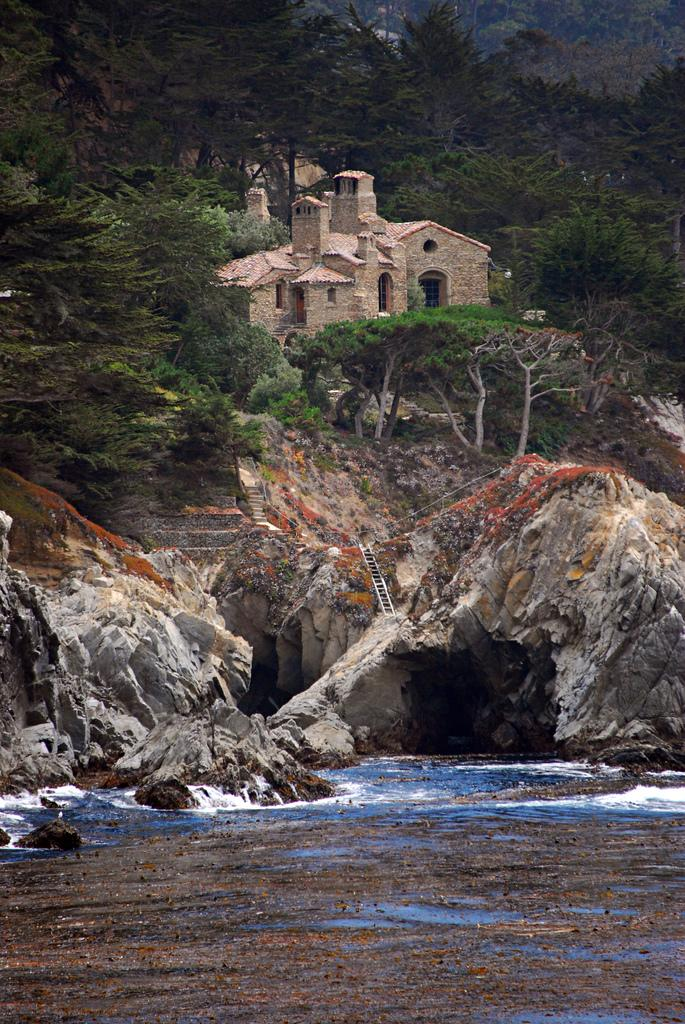What is located at the bottom of the image? There is a river at the bottom of the image. What can be seen in the background of the image? There are rocks, a ladder, trees, houses, and plants in the background of the image. What type of mouth can be seen on the ladder in the image? There is no mouth present on the ladder in the image. How many trips can be taken using the river in the image? The image does not provide information about the river's navigability or the possibility of taking trips on it. 